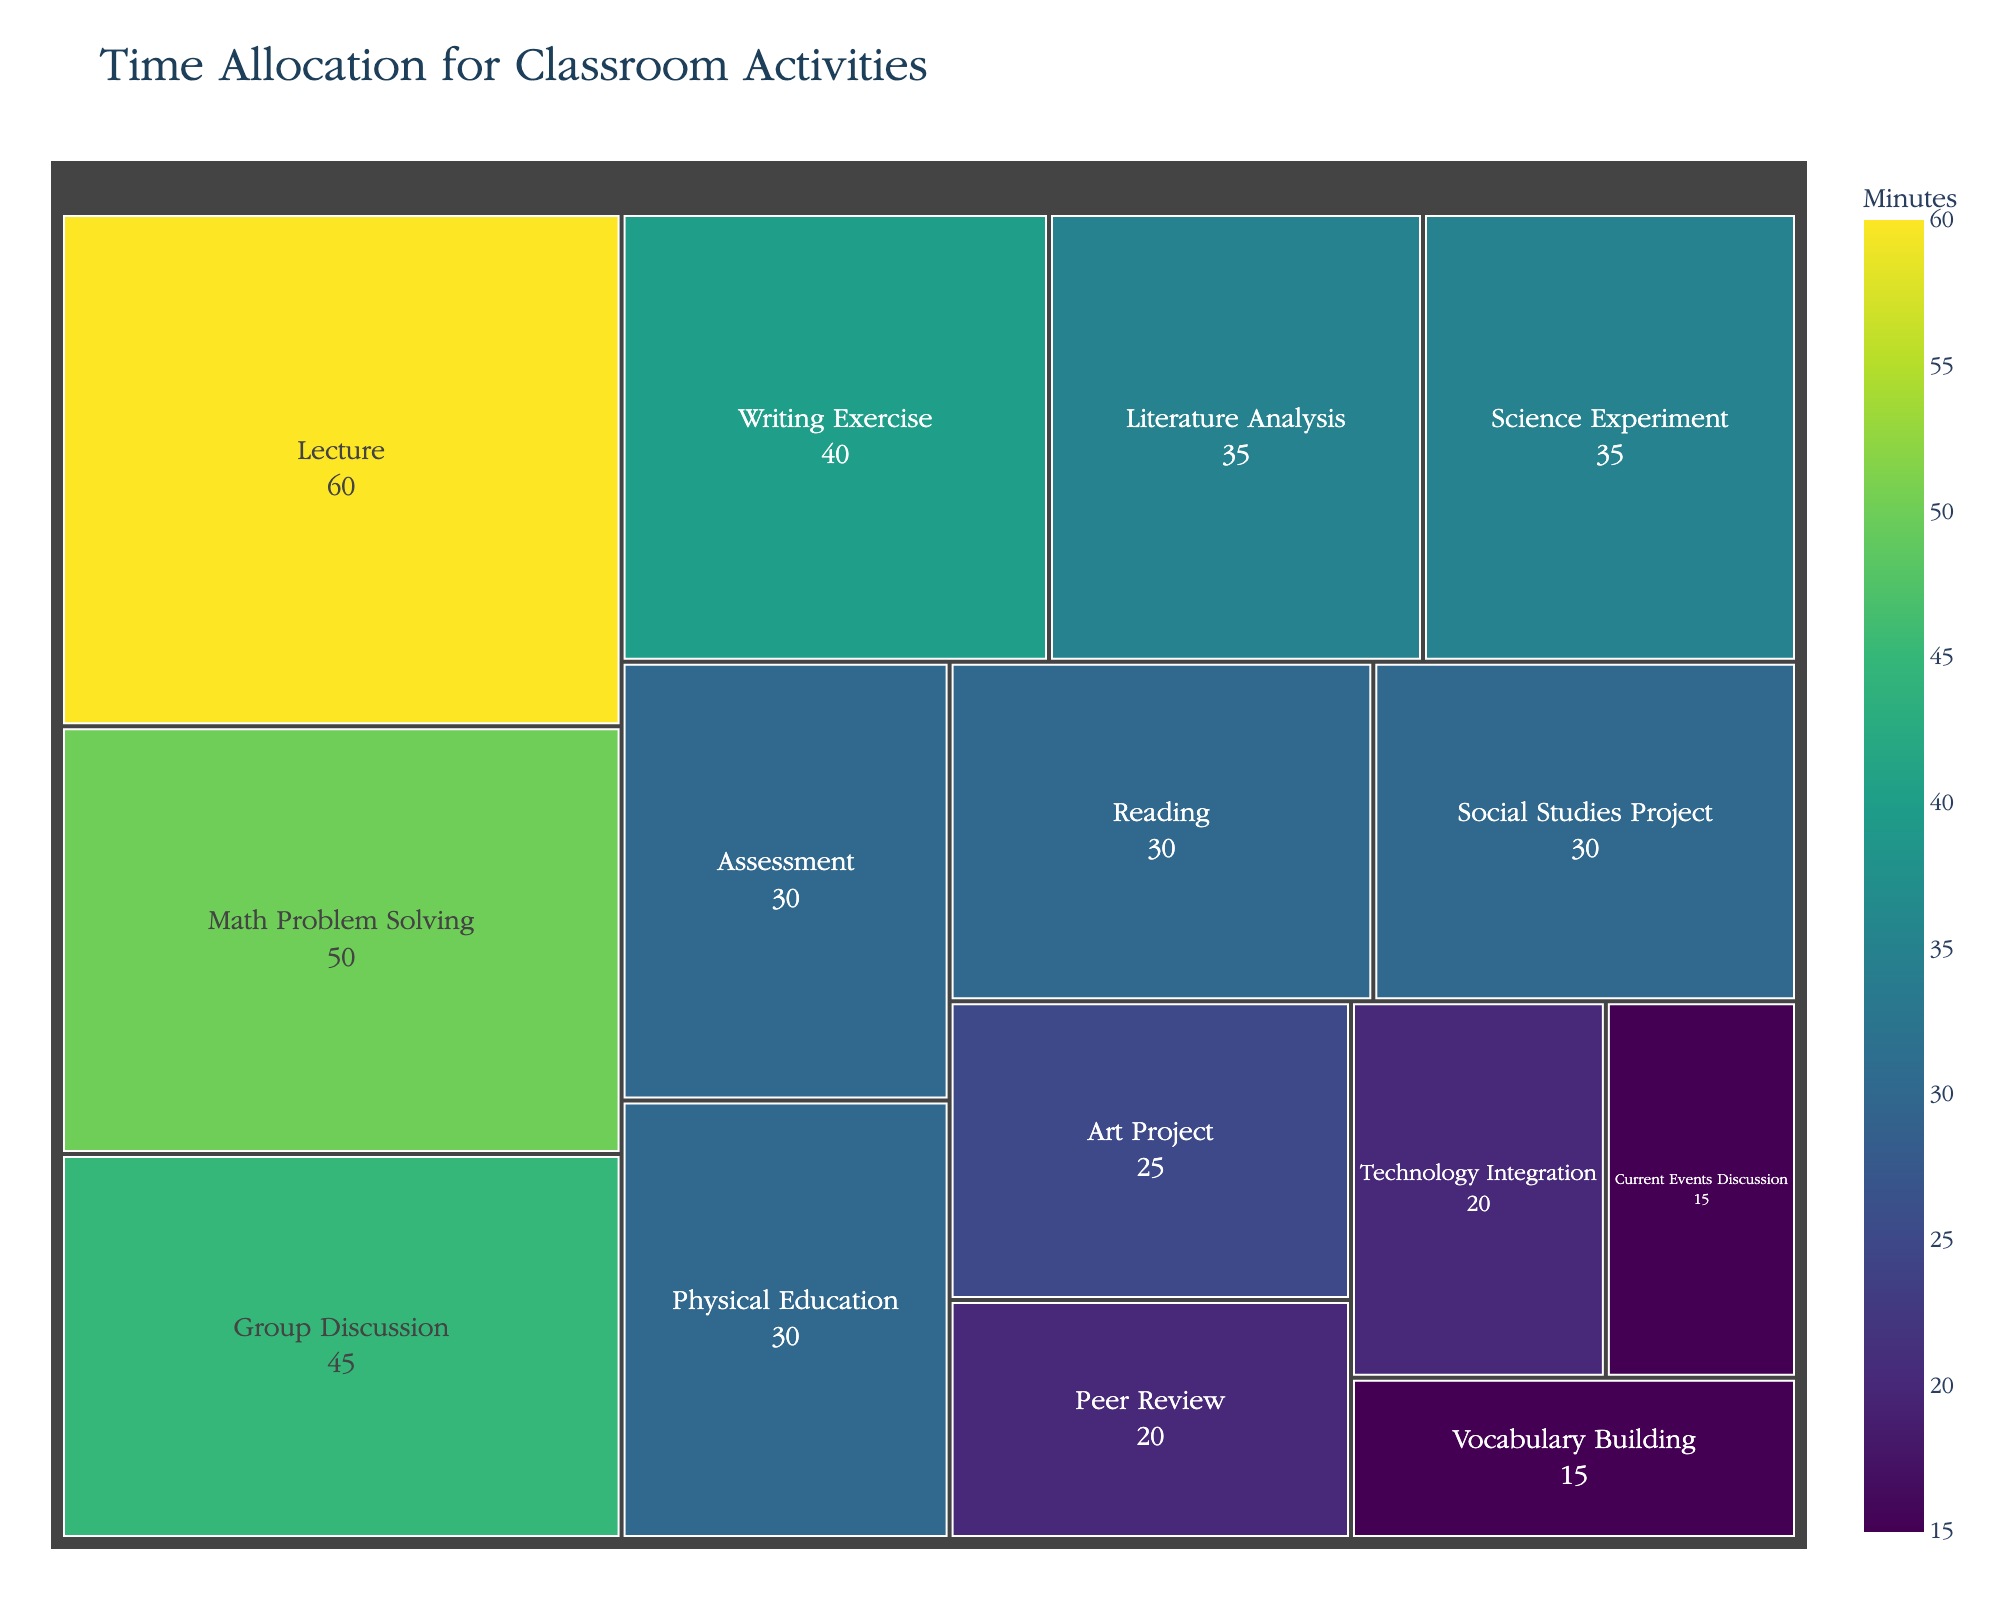What is the title of the figure? The title is visually found at the top center of the treemap. It summarizes what the data in the chart represents.
Answer: Time Allocation for Classroom Activities Which activity has the longest time allocation? Look for the largest rectangle on the treemap, as it represents the activity with the most time.
Answer: Lecture Between Group Discussion and Science Experiment, which one takes more time? Compare the sizes and time labels of the rectangles for Group Discussion and Science Experiment.
Answer: Group Discussion What is the total time allocated for Reading and Writing Exercise combined? Find the time values for Reading and Writing Exercise and sum them up: 30 + 40.
Answer: 70 minutes How does the time allocated for Physical Education compare to Technology Integration? Compare the rectangle sizes and time labels for Physical Education (30 minutes) and Technology Integration (20 minutes).
Answer: Physical Education is longer Which activity has the shortest time allocation? Identify the smallest rectangle in the treemap as it represents the least time allocated.
Answer: Vocabulary Building What is the average time allocation for all activities? Sum all time allocations and divide by the number of activities. (60+45+30+40+50+35+25+30+20+35+15+30+15+20+30) / 15 = 480/15.
Answer: 32 minutes Is the time for Math Problem Solving greater than or equal to the time for Science Experiment plus Art Project combined? Compare Math Problem Solving (50) to the sum of Science Experiment (35) and Art Project (25). 50 vs. 60.
Answer: No Which activity takes more time: Current Events Discussion or Peer Review? Compare the sizes and time labels of the rectangles for Current Events Discussion and Peer Review.
Answer: Peer Review If you want to split the total time equally among the activities, what would be the new time allocation for each? Divide the total time (480 minutes) by the number of activities (15). 480 / 15.
Answer: 32 minutes per activity 